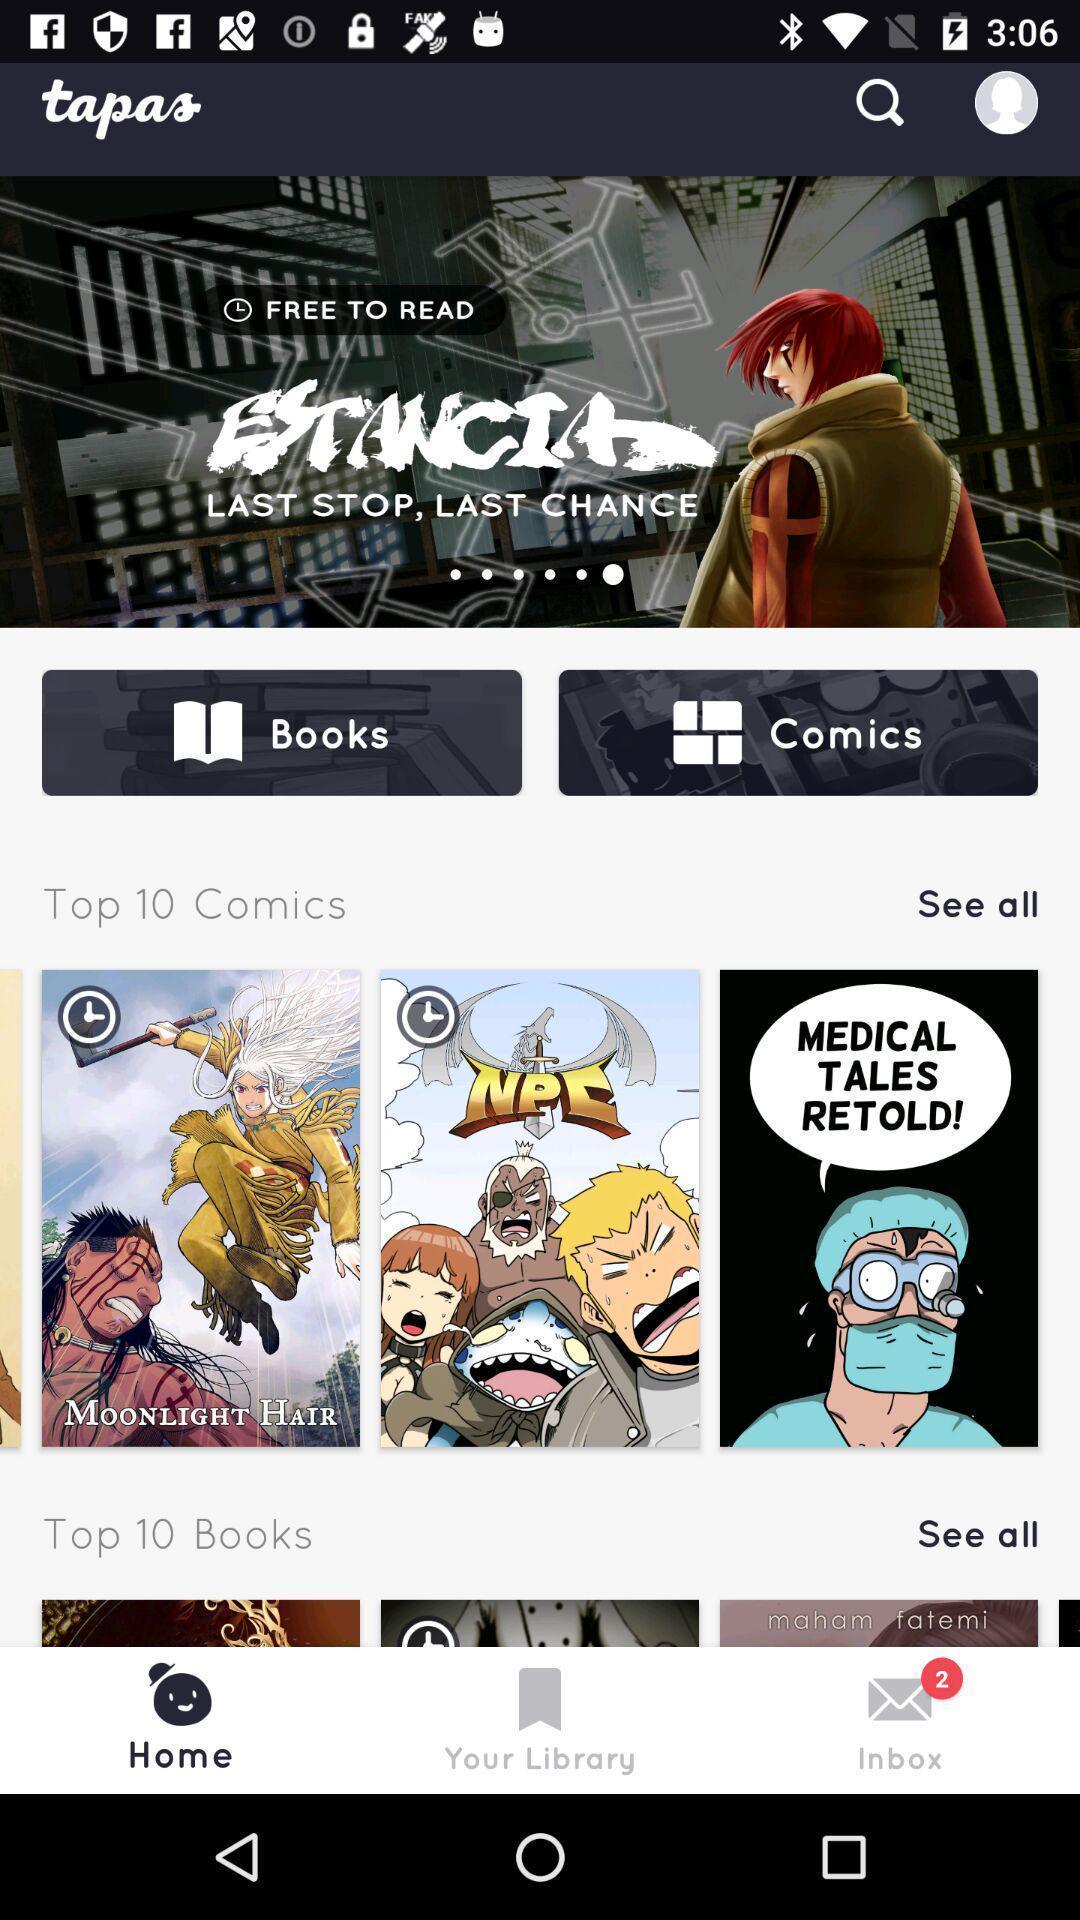Provide a textual representation of this image. Screen shows videos from an entertainment app. 